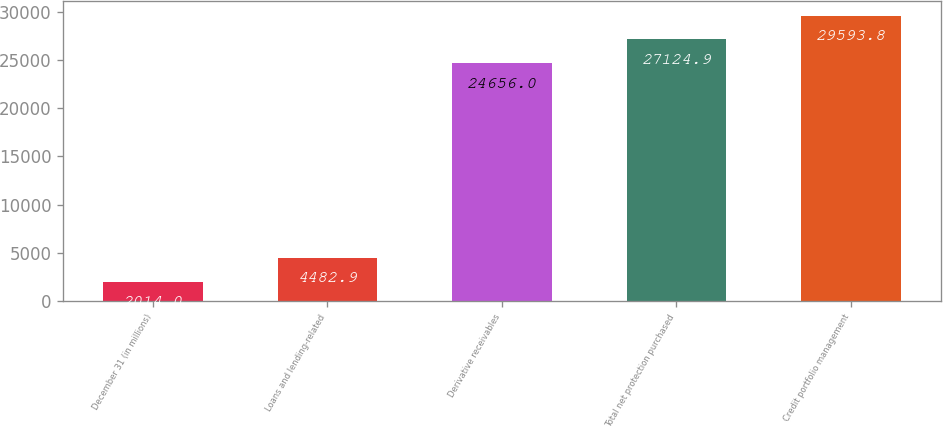<chart> <loc_0><loc_0><loc_500><loc_500><bar_chart><fcel>December 31 (in millions)<fcel>Loans and lending-related<fcel>Derivative receivables<fcel>Total net protection purchased<fcel>Credit portfolio management<nl><fcel>2014<fcel>4482.9<fcel>24656<fcel>27124.9<fcel>29593.8<nl></chart> 